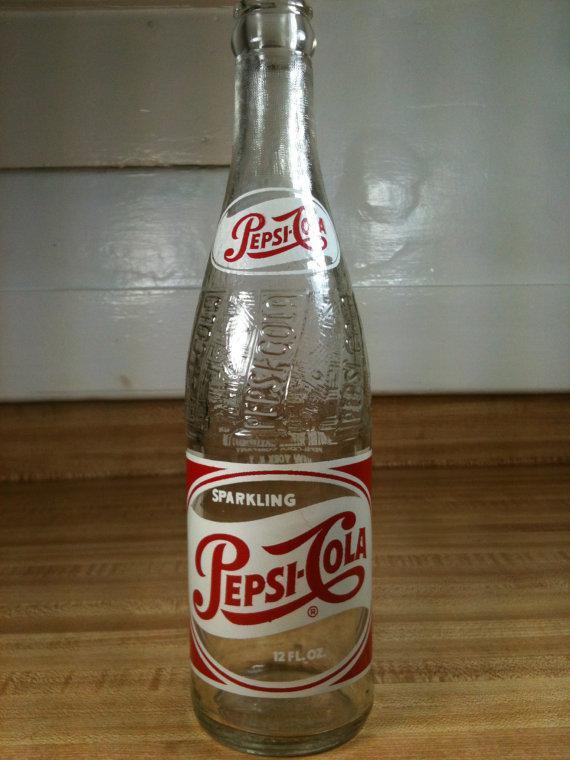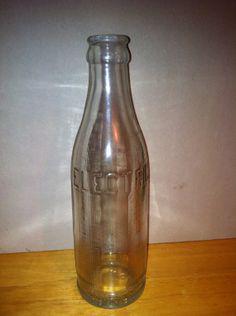The first image is the image on the left, the second image is the image on the right. Examine the images to the left and right. Is the description "There are more than three bottles." accurate? Answer yes or no. No. The first image is the image on the left, the second image is the image on the right. Analyze the images presented: Is the assertion "At least 5 bottles are standing side by side in one of the pictures." valid? Answer yes or no. No. 